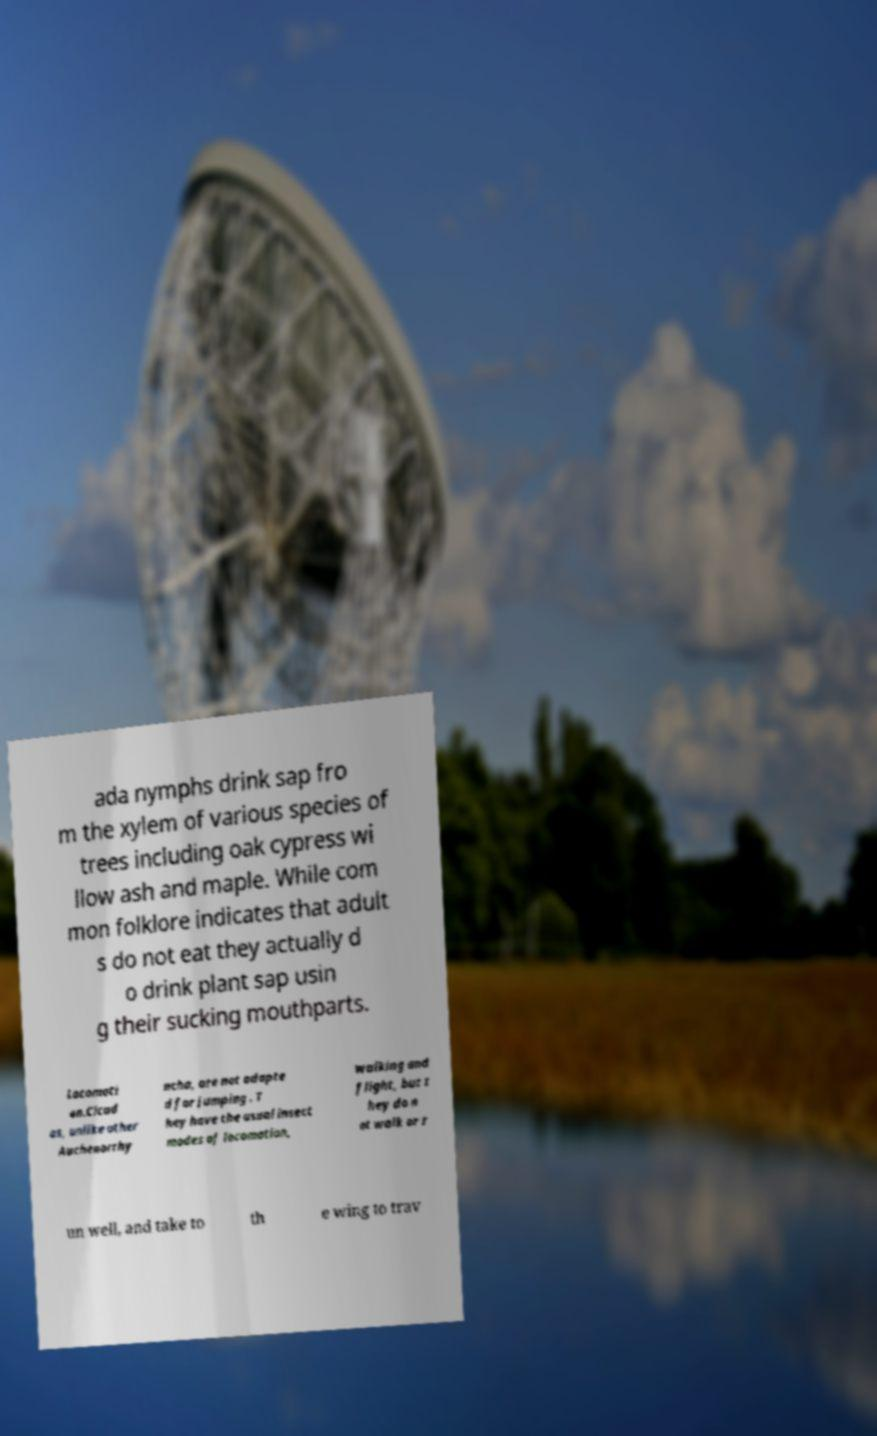What messages or text are displayed in this image? I need them in a readable, typed format. ada nymphs drink sap fro m the xylem of various species of trees including oak cypress wi llow ash and maple. While com mon folklore indicates that adult s do not eat they actually d o drink plant sap usin g their sucking mouthparts. Locomoti on.Cicad as, unlike other Auchenorrhy ncha, are not adapte d for jumping . T hey have the usual insect modes of locomotion, walking and flight, but t hey do n ot walk or r un well, and take to th e wing to trav 